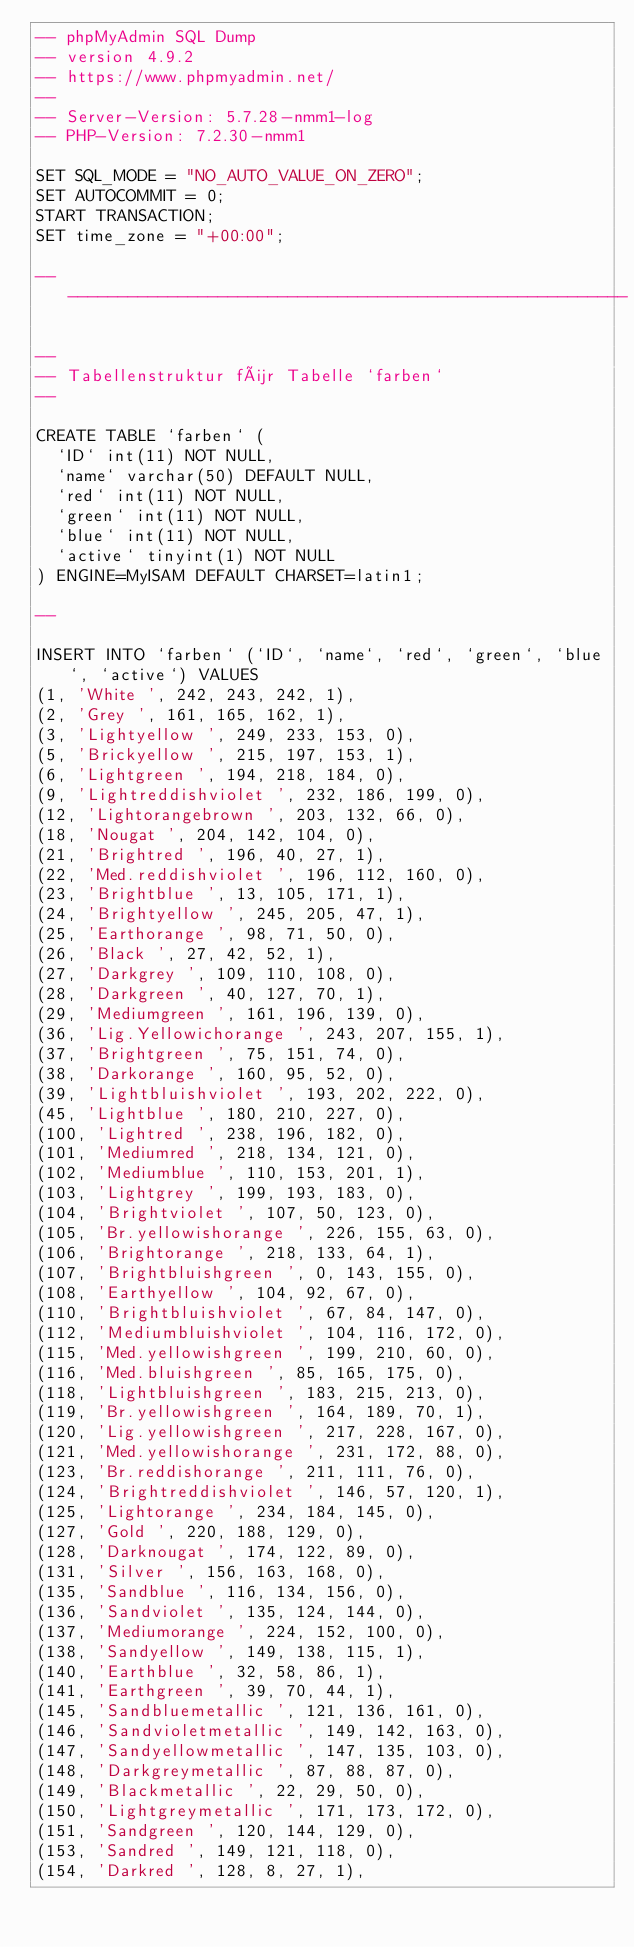Convert code to text. <code><loc_0><loc_0><loc_500><loc_500><_SQL_>-- phpMyAdmin SQL Dump
-- version 4.9.2
-- https://www.phpmyadmin.net/
--
-- Server-Version: 5.7.28-nmm1-log
-- PHP-Version: 7.2.30-nmm1

SET SQL_MODE = "NO_AUTO_VALUE_ON_ZERO";
SET AUTOCOMMIT = 0;
START TRANSACTION;
SET time_zone = "+00:00";

-- --------------------------------------------------------

--
-- Tabellenstruktur für Tabelle `farben`
--

CREATE TABLE `farben` (
  `ID` int(11) NOT NULL,
  `name` varchar(50) DEFAULT NULL,
  `red` int(11) NOT NULL,
  `green` int(11) NOT NULL,
  `blue` int(11) NOT NULL,
  `active` tinyint(1) NOT NULL
) ENGINE=MyISAM DEFAULT CHARSET=latin1;

--

INSERT INTO `farben` (`ID`, `name`, `red`, `green`, `blue`, `active`) VALUES
(1, 'White ', 242, 243, 242, 1),
(2, 'Grey ', 161, 165, 162, 1),
(3, 'Lightyellow ', 249, 233, 153, 0),
(5, 'Brickyellow ', 215, 197, 153, 1),
(6, 'Lightgreen ', 194, 218, 184, 0),
(9, 'Lightreddishviolet ', 232, 186, 199, 0),
(12, 'Lightorangebrown ', 203, 132, 66, 0),
(18, 'Nougat ', 204, 142, 104, 0),
(21, 'Brightred ', 196, 40, 27, 1),
(22, 'Med.reddishviolet ', 196, 112, 160, 0),
(23, 'Brightblue ', 13, 105, 171, 1),
(24, 'Brightyellow ', 245, 205, 47, 1),
(25, 'Earthorange ', 98, 71, 50, 0),
(26, 'Black ', 27, 42, 52, 1),
(27, 'Darkgrey ', 109, 110, 108, 0),
(28, 'Darkgreen ', 40, 127, 70, 1),
(29, 'Mediumgreen ', 161, 196, 139, 0),
(36, 'Lig.Yellowichorange ', 243, 207, 155, 1),
(37, 'Brightgreen ', 75, 151, 74, 0),
(38, 'Darkorange ', 160, 95, 52, 0),
(39, 'Lightbluishviolet ', 193, 202, 222, 0),
(45, 'Lightblue ', 180, 210, 227, 0),
(100, 'Lightred ', 238, 196, 182, 0),
(101, 'Mediumred ', 218, 134, 121, 0),
(102, 'Mediumblue ', 110, 153, 201, 1),
(103, 'Lightgrey ', 199, 193, 183, 0),
(104, 'Brightviolet ', 107, 50, 123, 0),
(105, 'Br.yellowishorange ', 226, 155, 63, 0),
(106, 'Brightorange ', 218, 133, 64, 1),
(107, 'Brightbluishgreen ', 0, 143, 155, 0),
(108, 'Earthyellow ', 104, 92, 67, 0),
(110, 'Brightbluishviolet ', 67, 84, 147, 0),
(112, 'Mediumbluishviolet ', 104, 116, 172, 0),
(115, 'Med.yellowishgreen ', 199, 210, 60, 0),
(116, 'Med.bluishgreen ', 85, 165, 175, 0),
(118, 'Lightbluishgreen ', 183, 215, 213, 0),
(119, 'Br.yellowishgreen ', 164, 189, 70, 1),
(120, 'Lig.yellowishgreen ', 217, 228, 167, 0),
(121, 'Med.yellowishorange ', 231, 172, 88, 0),
(123, 'Br.reddishorange ', 211, 111, 76, 0),
(124, 'Brightreddishviolet ', 146, 57, 120, 1),
(125, 'Lightorange ', 234, 184, 145, 0),
(127, 'Gold ', 220, 188, 129, 0),
(128, 'Darknougat ', 174, 122, 89, 0),
(131, 'Silver ', 156, 163, 168, 0),
(135, 'Sandblue ', 116, 134, 156, 0),
(136, 'Sandviolet ', 135, 124, 144, 0),
(137, 'Mediumorange ', 224, 152, 100, 0),
(138, 'Sandyellow ', 149, 138, 115, 1),
(140, 'Earthblue ', 32, 58, 86, 1),
(141, 'Earthgreen ', 39, 70, 44, 1),
(145, 'Sandbluemetallic ', 121, 136, 161, 0),
(146, 'Sandvioletmetallic ', 149, 142, 163, 0),
(147, 'Sandyellowmetallic ', 147, 135, 103, 0),
(148, 'Darkgreymetallic ', 87, 88, 87, 0),
(149, 'Blackmetallic ', 22, 29, 50, 0),
(150, 'Lightgreymetallic ', 171, 173, 172, 0),
(151, 'Sandgreen ', 120, 144, 129, 0),
(153, 'Sandred ', 149, 121, 118, 0),
(154, 'Darkred ', 128, 8, 27, 1),</code> 